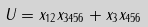<formula> <loc_0><loc_0><loc_500><loc_500>U = x _ { 1 2 } x _ { 3 4 5 6 } + x _ { 3 } x _ { 4 5 6 }</formula> 